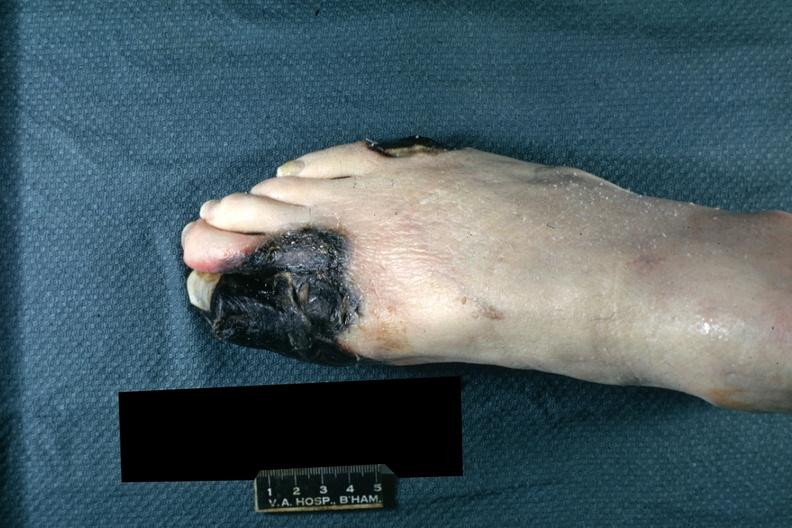what does this image show?
Answer the question using a single word or phrase. Well demarcated black tissue great and second toe and lateral aspect of small toe 